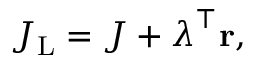Convert formula to latex. <formula><loc_0><loc_0><loc_500><loc_500>\begin{array} { r } { J _ { L } = J + \lambda ^ { \top } { r } , } \end{array}</formula> 